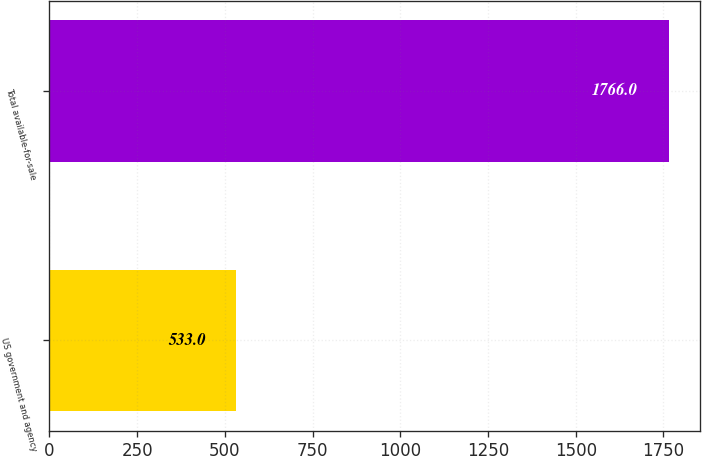Convert chart to OTSL. <chart><loc_0><loc_0><loc_500><loc_500><bar_chart><fcel>US government and agency<fcel>Total available-for-sale<nl><fcel>533<fcel>1766<nl></chart> 